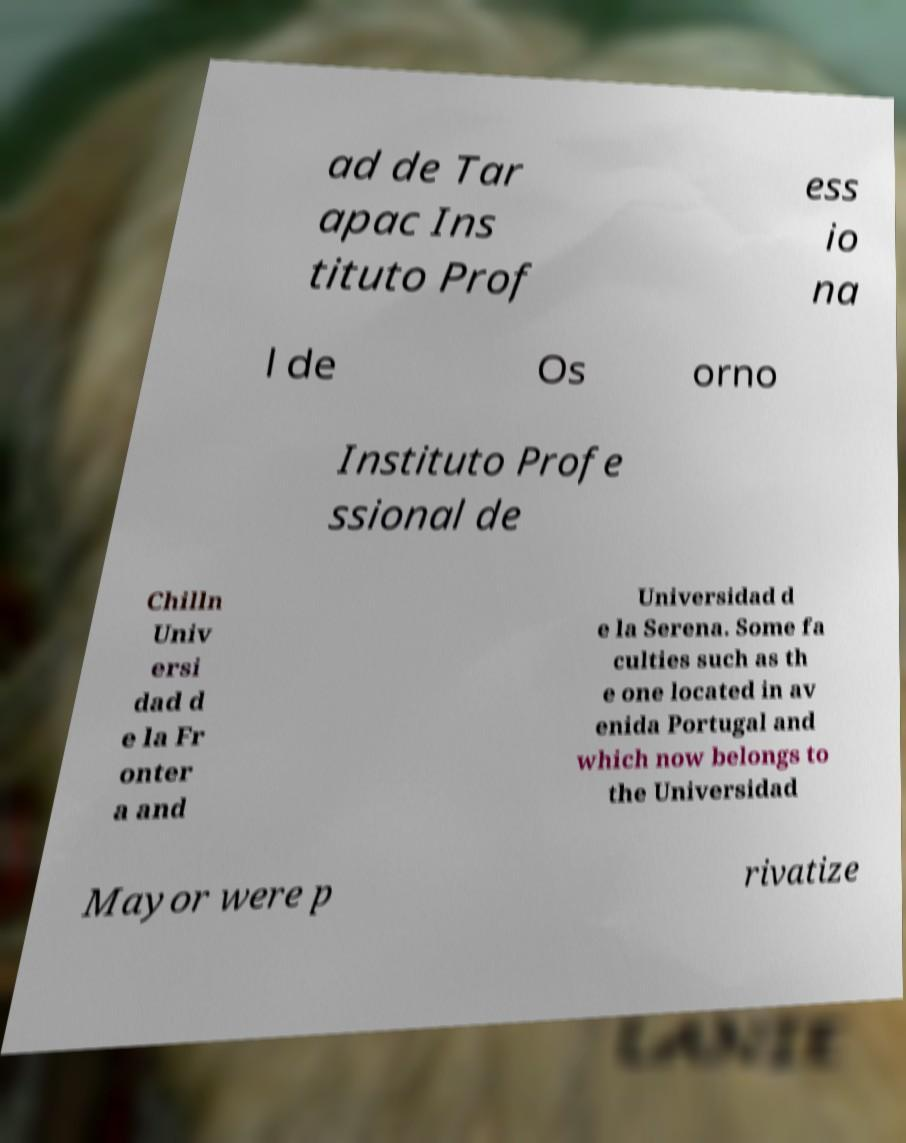Please read and relay the text visible in this image. What does it say? ad de Tar apac Ins tituto Prof ess io na l de Os orno Instituto Profe ssional de Chilln Univ ersi dad d e la Fr onter a and Universidad d e la Serena. Some fa culties such as th e one located in av enida Portugal and which now belongs to the Universidad Mayor were p rivatize 